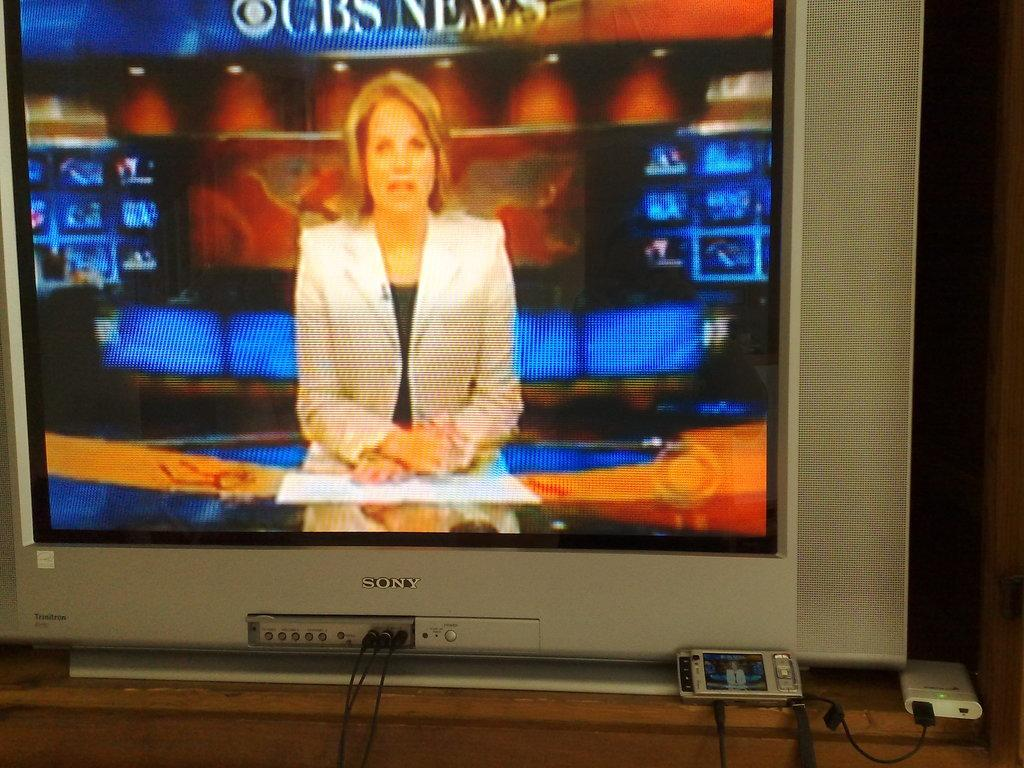<image>
Share a concise interpretation of the image provided. A CBS news anchor is going over today's news. 